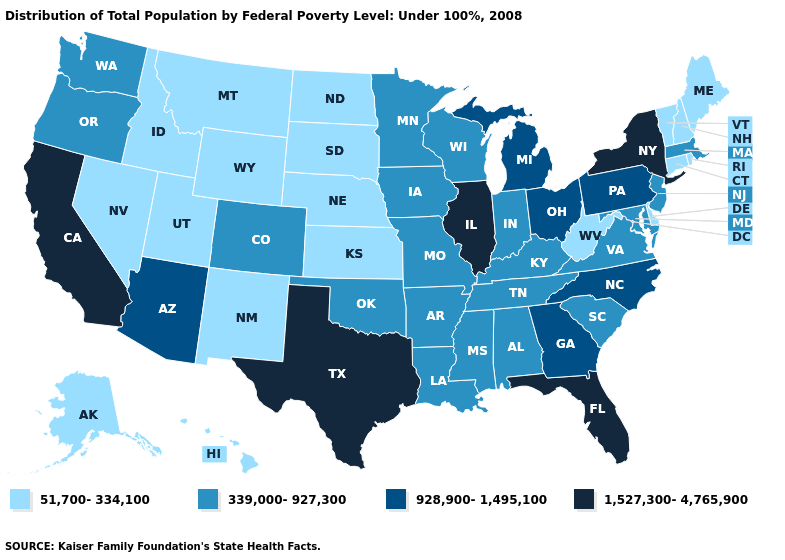Does New York have the highest value in the USA?
Short answer required. Yes. Is the legend a continuous bar?
Quick response, please. No. Name the states that have a value in the range 339,000-927,300?
Quick response, please. Alabama, Arkansas, Colorado, Indiana, Iowa, Kentucky, Louisiana, Maryland, Massachusetts, Minnesota, Mississippi, Missouri, New Jersey, Oklahoma, Oregon, South Carolina, Tennessee, Virginia, Washington, Wisconsin. Name the states that have a value in the range 928,900-1,495,100?
Be succinct. Arizona, Georgia, Michigan, North Carolina, Ohio, Pennsylvania. What is the lowest value in the USA?
Concise answer only. 51,700-334,100. What is the highest value in states that border Michigan?
Answer briefly. 928,900-1,495,100. Name the states that have a value in the range 928,900-1,495,100?
Give a very brief answer. Arizona, Georgia, Michigan, North Carolina, Ohio, Pennsylvania. Does New York have the highest value in the Northeast?
Quick response, please. Yes. Is the legend a continuous bar?
Concise answer only. No. What is the highest value in the USA?
Be succinct. 1,527,300-4,765,900. What is the value of Rhode Island?
Keep it brief. 51,700-334,100. Is the legend a continuous bar?
Keep it brief. No. Which states have the lowest value in the USA?
Quick response, please. Alaska, Connecticut, Delaware, Hawaii, Idaho, Kansas, Maine, Montana, Nebraska, Nevada, New Hampshire, New Mexico, North Dakota, Rhode Island, South Dakota, Utah, Vermont, West Virginia, Wyoming. Name the states that have a value in the range 51,700-334,100?
Quick response, please. Alaska, Connecticut, Delaware, Hawaii, Idaho, Kansas, Maine, Montana, Nebraska, Nevada, New Hampshire, New Mexico, North Dakota, Rhode Island, South Dakota, Utah, Vermont, West Virginia, Wyoming. What is the value of Texas?
Concise answer only. 1,527,300-4,765,900. 